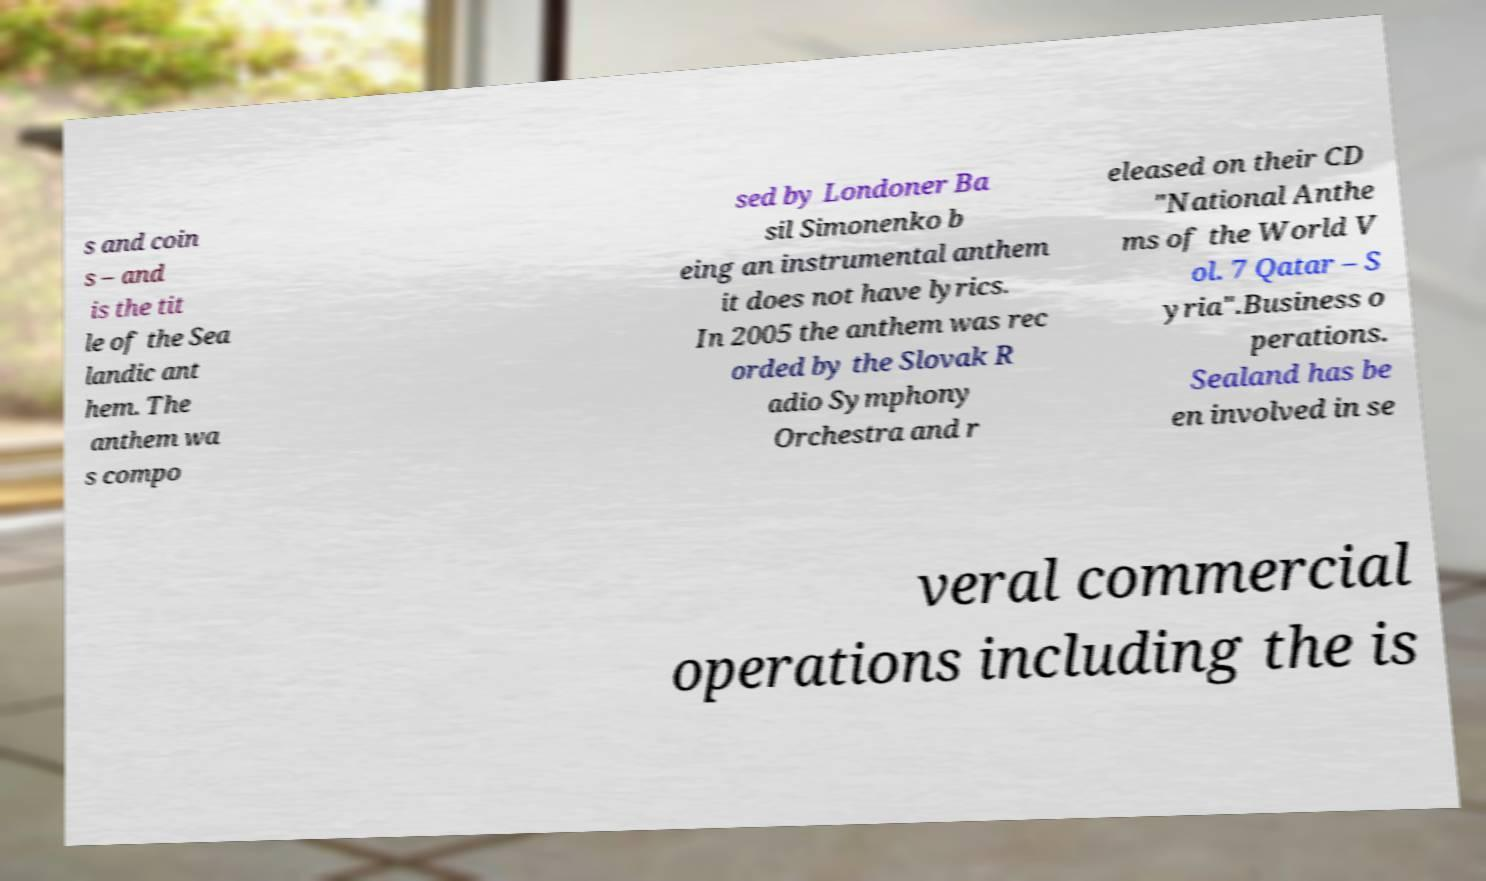Could you extract and type out the text from this image? s and coin s – and is the tit le of the Sea landic ant hem. The anthem wa s compo sed by Londoner Ba sil Simonenko b eing an instrumental anthem it does not have lyrics. In 2005 the anthem was rec orded by the Slovak R adio Symphony Orchestra and r eleased on their CD "National Anthe ms of the World V ol. 7 Qatar – S yria".Business o perations. Sealand has be en involved in se veral commercial operations including the is 